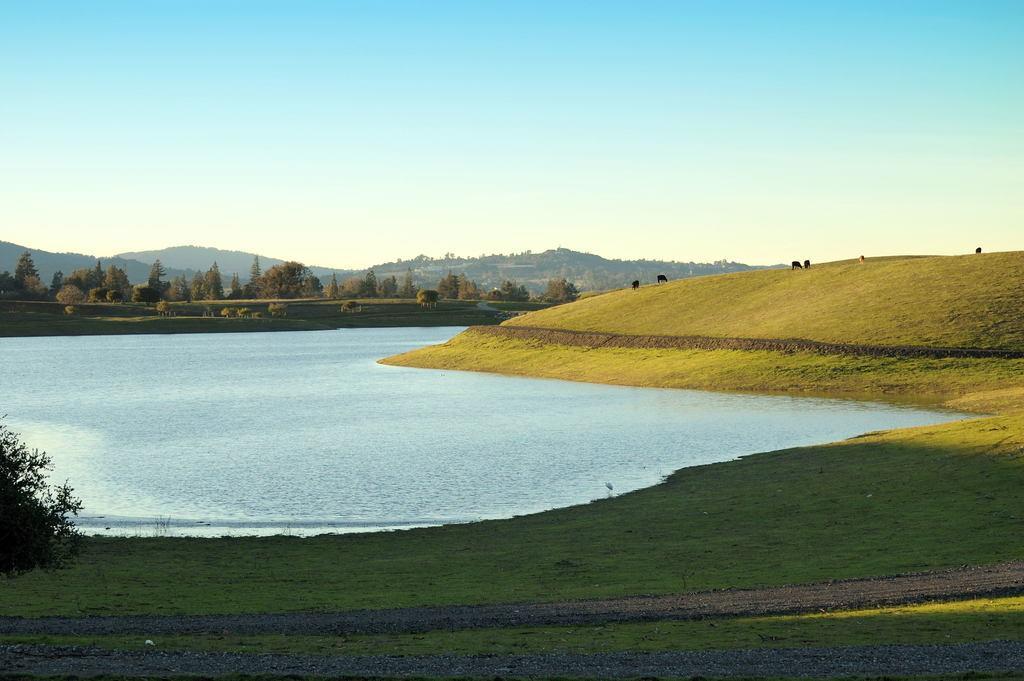How would you summarize this image in a sentence or two? In this image there are few animals grazing in the grass, few trees, plants, water, mountains and the sky. 